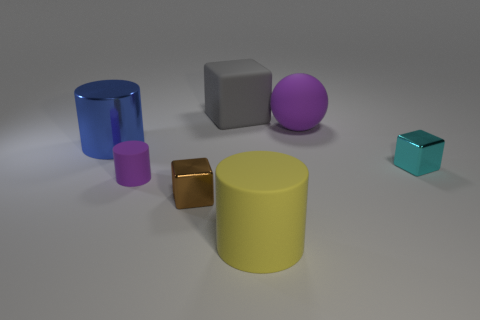Add 2 big matte objects. How many objects exist? 9 Subtract all cubes. How many objects are left? 4 Add 7 blue metal things. How many blue metal things exist? 8 Subtract 1 gray blocks. How many objects are left? 6 Subtract all brown cubes. Subtract all cyan shiny things. How many objects are left? 5 Add 6 big yellow matte objects. How many big yellow matte objects are left? 7 